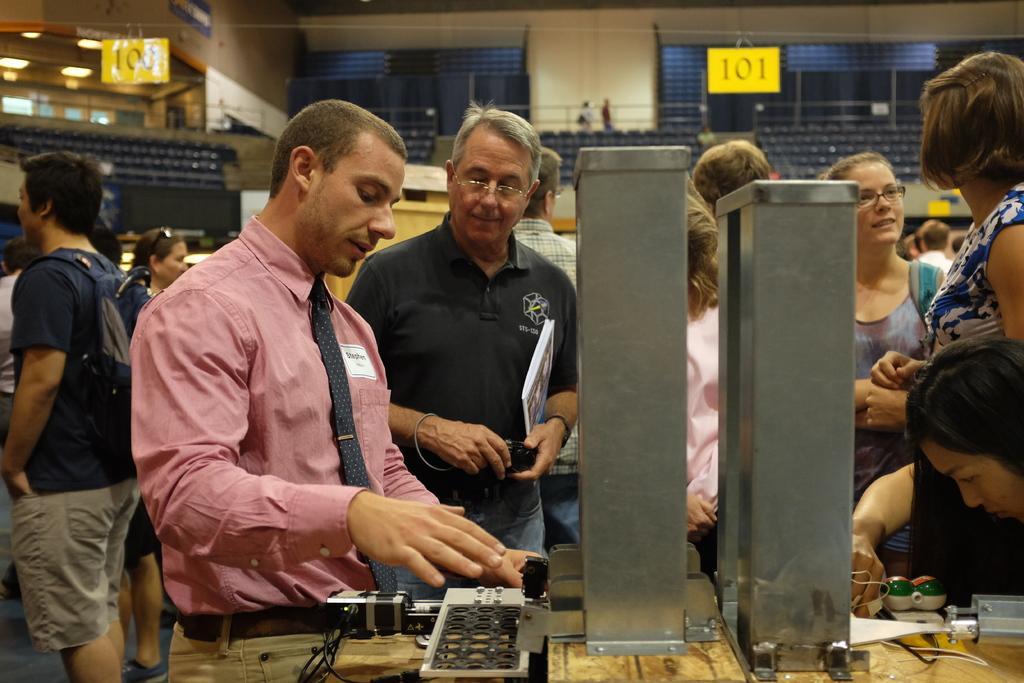Could you give a brief overview of what you see in this image? In this image we can see few persons are standing and among them few are carrying bags on their shoulders and a person is holding a camera in his hands and a book under his arm. At the bottom there are metal objects and a device on a platform. In the background there are chairs, poles, lights on the ceiling, boards tied to the rope and few persons. 